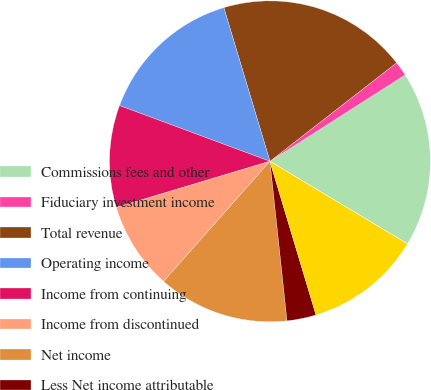Convert chart. <chart><loc_0><loc_0><loc_500><loc_500><pie_chart><fcel>Commissions fees and other<fcel>Fiduciary investment income<fcel>Total revenue<fcel>Operating income<fcel>Income from continuing<fcel>Income from discontinued<fcel>Net income<fcel>Less Net income attributable<fcel>Net income attributable to Aon<fcel>Dividends paid per share<nl><fcel>17.65%<fcel>1.47%<fcel>19.12%<fcel>14.71%<fcel>10.29%<fcel>8.82%<fcel>13.23%<fcel>2.94%<fcel>11.76%<fcel>0.0%<nl></chart> 